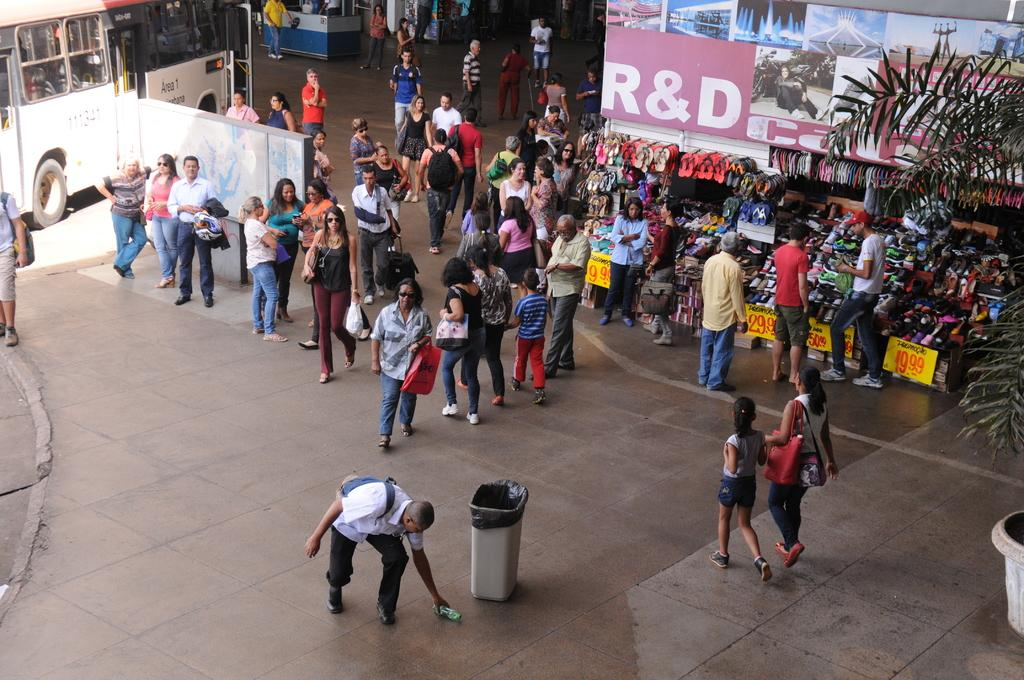What are the people in the image doing? There is a group of people on the floor in the image. What can be seen in the image besides the people? There is a dustbin, bags, posters, a plant, footwear, a bus, and some unspecified objects in the image. What type of whistle can be heard coming from the bus in the image? There is no whistle present in the image, and therefore no sound can be heard. 